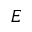<formula> <loc_0><loc_0><loc_500><loc_500>E</formula> 